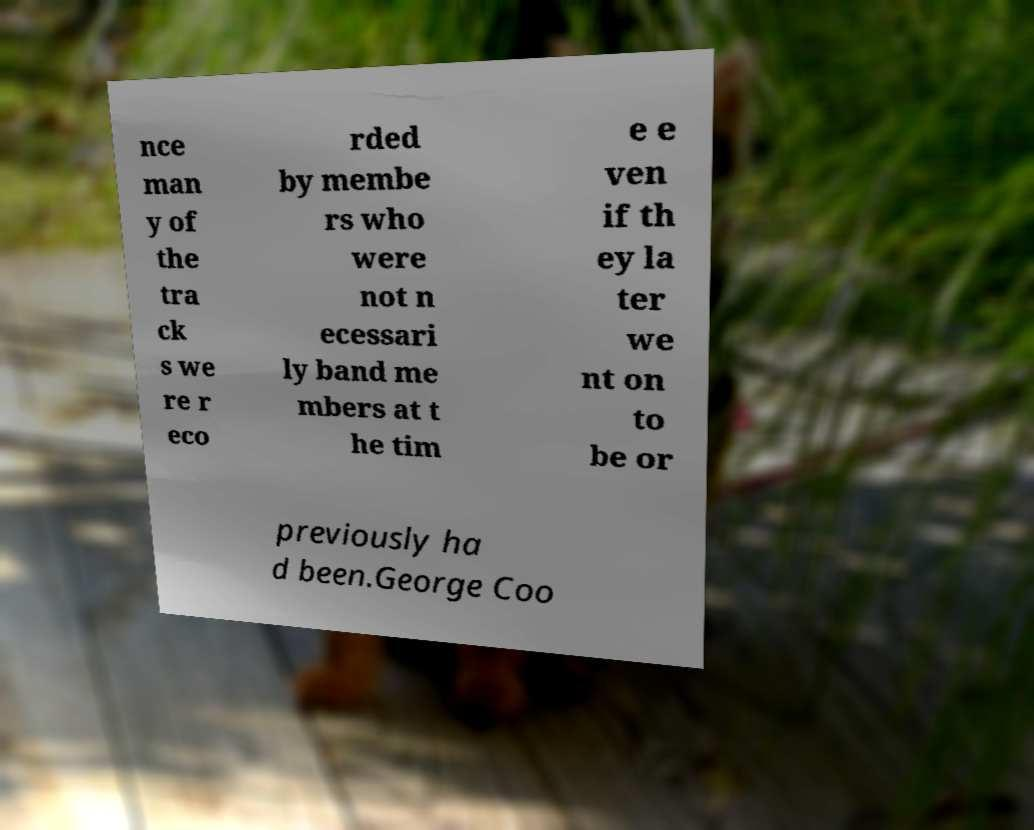Could you extract and type out the text from this image? nce man y of the tra ck s we re r eco rded by membe rs who were not n ecessari ly band me mbers at t he tim e e ven if th ey la ter we nt on to be or previously ha d been.George Coo 